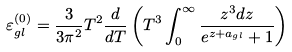Convert formula to latex. <formula><loc_0><loc_0><loc_500><loc_500>\varepsilon ^ { ( 0 ) } _ { g l } = \frac { 3 } { 3 \pi ^ { 2 } } T ^ { 2 } \frac { d } { d T } \left ( T ^ { 3 } \int _ { 0 } ^ { \infty } \frac { z ^ { 3 } d z } { e ^ { z + a _ { g l } } + 1 } \right )</formula> 